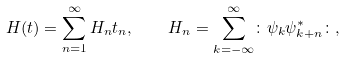<formula> <loc_0><loc_0><loc_500><loc_500>H ( t ) = \sum ^ { \infty } _ { n = 1 } H _ { n } t _ { n } , \quad H _ { n } = \sum _ { k = - \infty } ^ { \infty } \colon \psi _ { k } \psi _ { k + n } ^ { * } \colon ,</formula> 